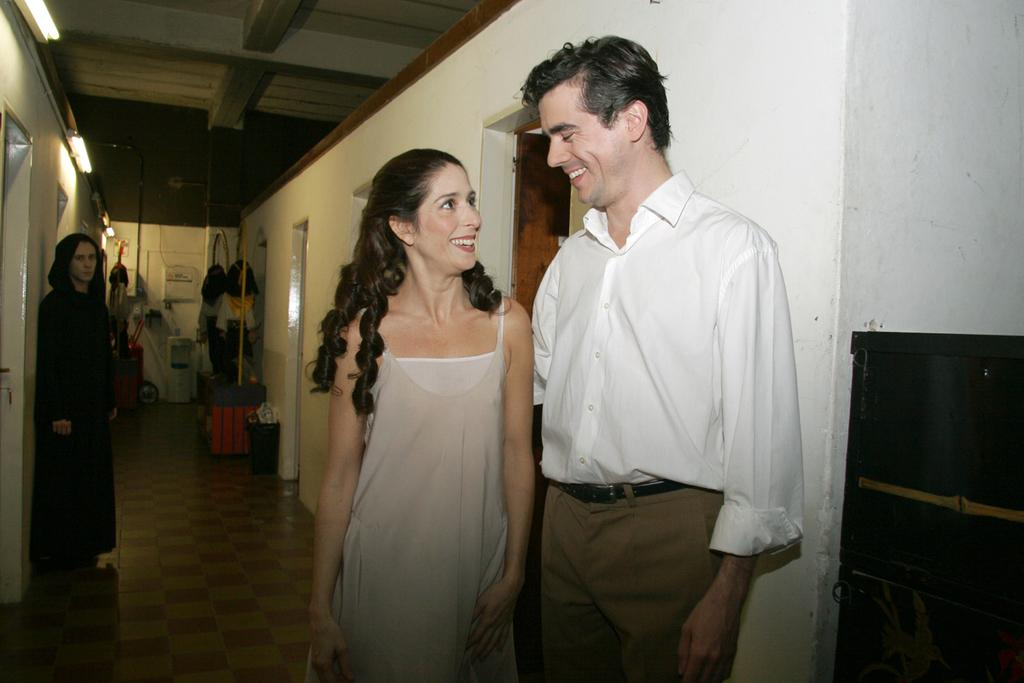Who is present in the image? There are people in the image. Can you describe the two main subjects in the image? A man and a woman are in the middle of the image. What expressions do the man and the woman have? The man and the woman are both smiling. What can be seen in the background of the image? There are clothes and lights in the background of the image. What type of fruit is being shared between the man and the woman in the image? There is no fruit present in the image; the man and the woman are simply smiling. What kind of connection can be seen between the man and the woman in the image? The image does not show any specific connection between the man and the woman beyond their smiles. 